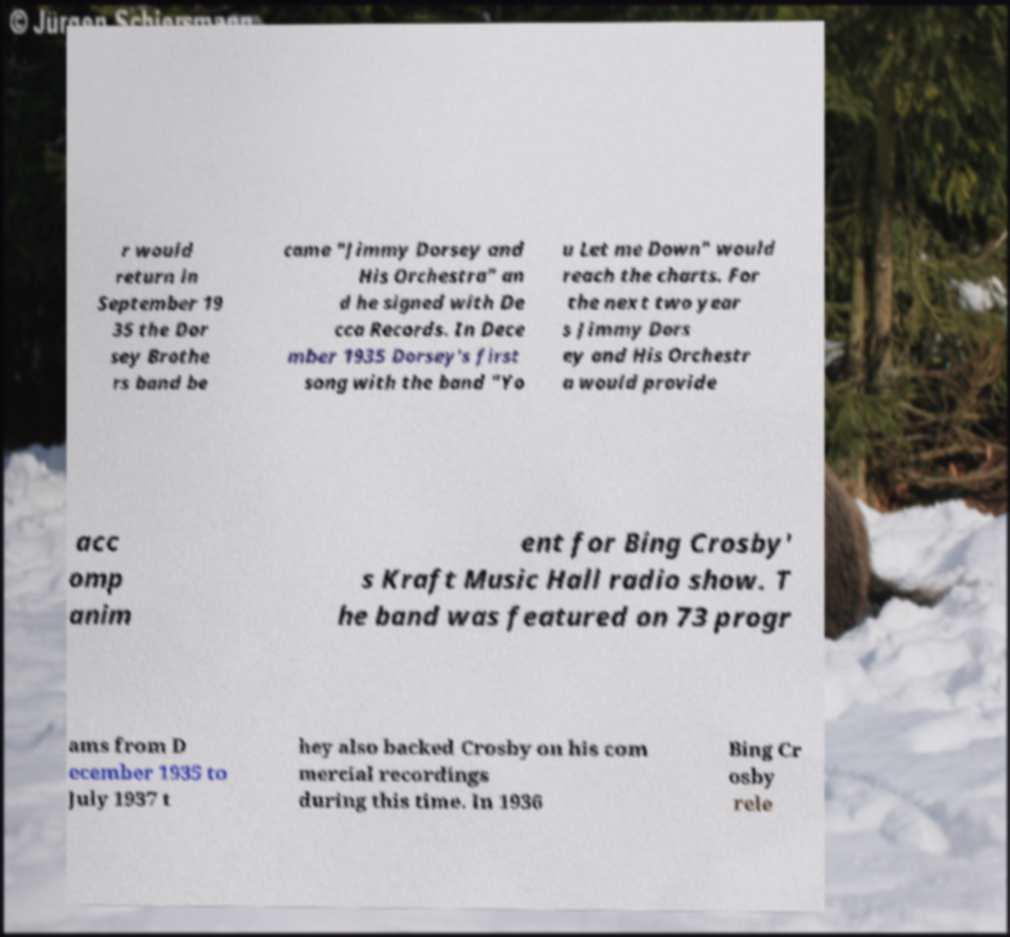For documentation purposes, I need the text within this image transcribed. Could you provide that? r would return in September 19 35 the Dor sey Brothe rs band be came "Jimmy Dorsey and His Orchestra" an d he signed with De cca Records. In Dece mber 1935 Dorsey's first song with the band "Yo u Let me Down" would reach the charts. For the next two year s Jimmy Dors ey and His Orchestr a would provide acc omp anim ent for Bing Crosby' s Kraft Music Hall radio show. T he band was featured on 73 progr ams from D ecember 1935 to July 1937 t hey also backed Crosby on his com mercial recordings during this time. In 1936 Bing Cr osby rele 